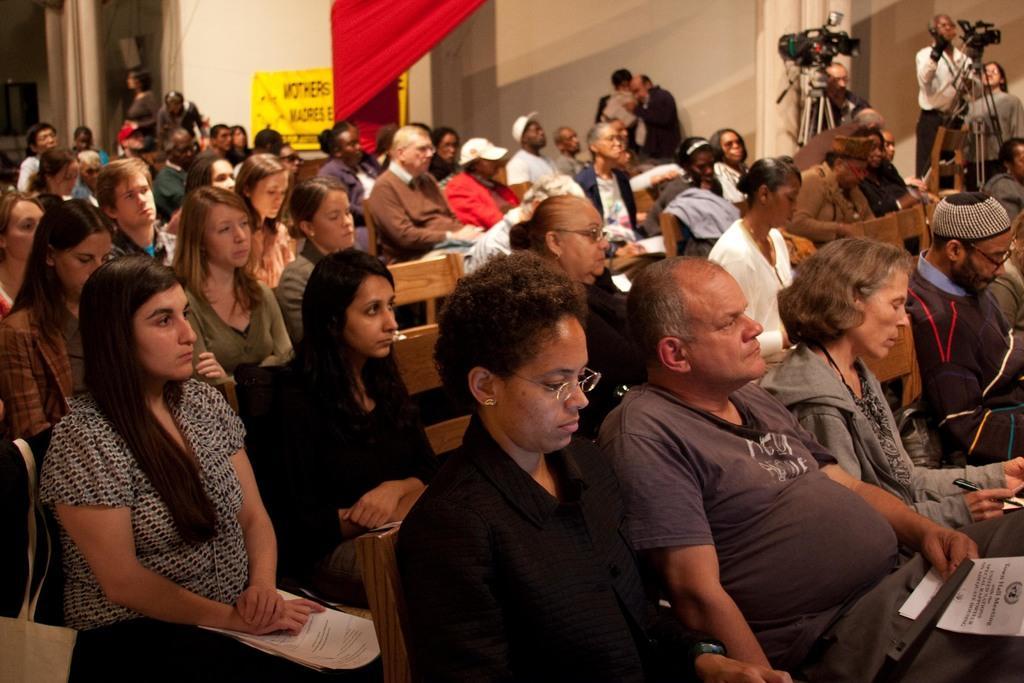Could you give a brief overview of what you see in this image? In this image we can see a few people sitting on the chairs, also we can some people standing, there are cameras and a poster with some text on the wall, also we can see a curtain. 